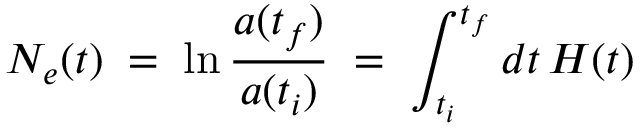<formula> <loc_0><loc_0><loc_500><loc_500>N _ { e } ( t ) \, = \, \ln { \frac { a ( t _ { f } ) } { a ( t _ { i } ) } } \, = \, \int _ { t _ { i } } ^ { t _ { f } } d t \, H ( t )</formula> 